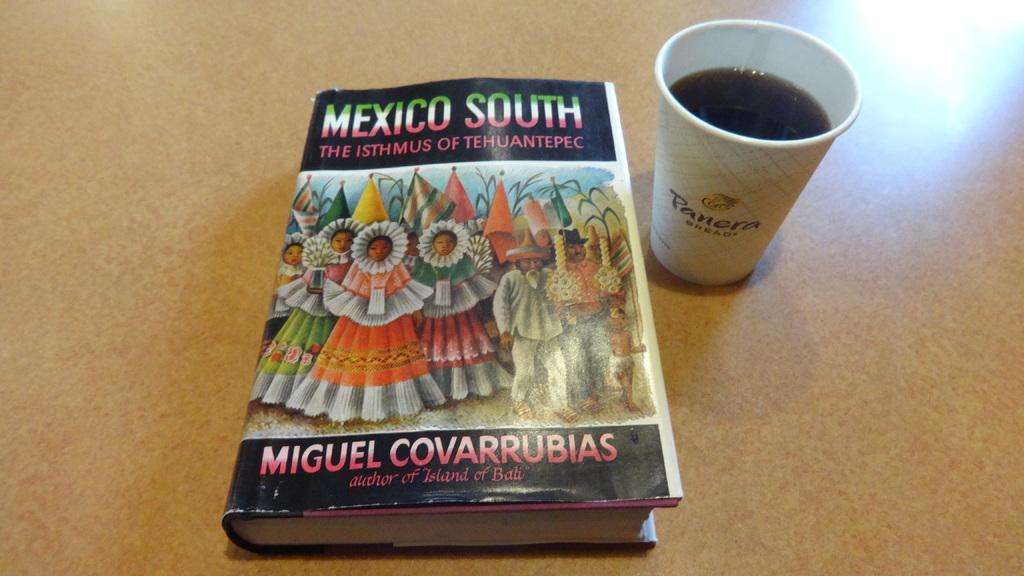Who wrote,"mexico south"?
Your answer should be compact. Miguel covarrubias. Where is the coffee from?
Give a very brief answer. Panera. 